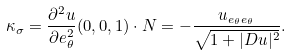Convert formula to latex. <formula><loc_0><loc_0><loc_500><loc_500>\kappa _ { \sigma } = \frac { \partial ^ { 2 } u } { \partial e _ { \theta } ^ { 2 } } ( 0 , 0 , 1 ) \cdot N = - \frac { u _ { e _ { \theta } e _ { \theta } } } { \sqrt { 1 + | D u | ^ { 2 } } } .</formula> 